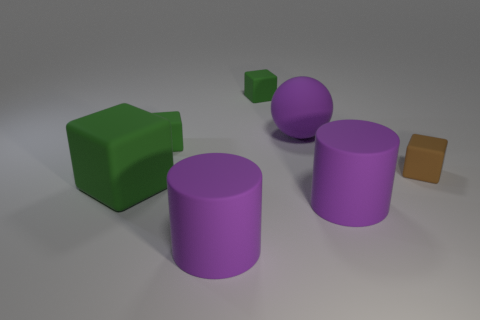Subtract all tiny cubes. How many cubes are left? 1 Add 1 red metallic balls. How many objects exist? 8 Subtract all brown cubes. How many cubes are left? 3 Subtract all balls. How many objects are left? 6 Add 4 small things. How many small things are left? 7 Add 4 matte cubes. How many matte cubes exist? 8 Subtract 0 red cylinders. How many objects are left? 7 Subtract 1 cylinders. How many cylinders are left? 1 Subtract all brown cylinders. Subtract all purple spheres. How many cylinders are left? 2 Subtract all green balls. How many brown blocks are left? 1 